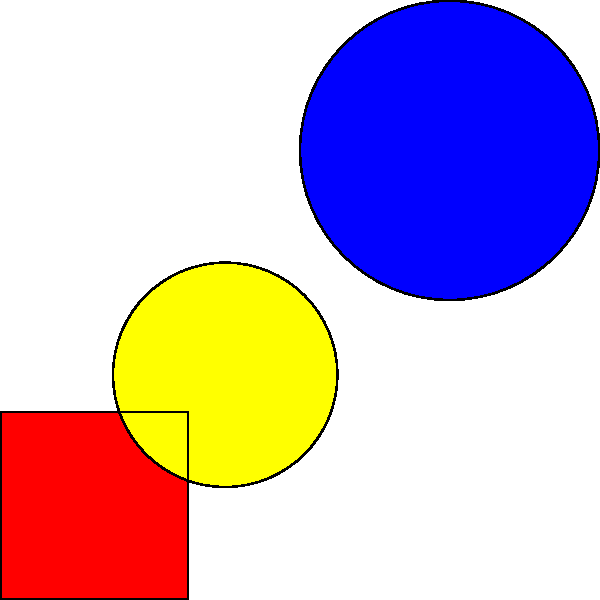Identify the avant-garde art movement most closely associated with the geometric composition shown above, featuring a red square, blue triangle, and yellow circle arranged in a non-representational manner. 1. Observe the geometric shapes: a red square, blue triangle, and yellow circle.
2. Note the non-representational arrangement of these shapes.
3. Recognize the use of primary colors (red, blue, yellow) and basic geometric forms.
4. Recall that these elements are characteristic of the De Stijl movement, founded in 1917.
5. De Stijl, led by Theo van Doesburg and Piet Mondrian, emphasized abstraction and simplification.
6. The movement sought to express universal harmonies through pure geometric forms and primary colors.
7. This composition reflects De Stijl's principles of reducing art to its essential elements.
8. Other movements like Suprematism used similar elements but typically favored white backgrounds and more dynamic compositions.
9. The balanced, static arrangement here is more in line with De Stijl's aesthetic philosophy.
Answer: De Stijl 